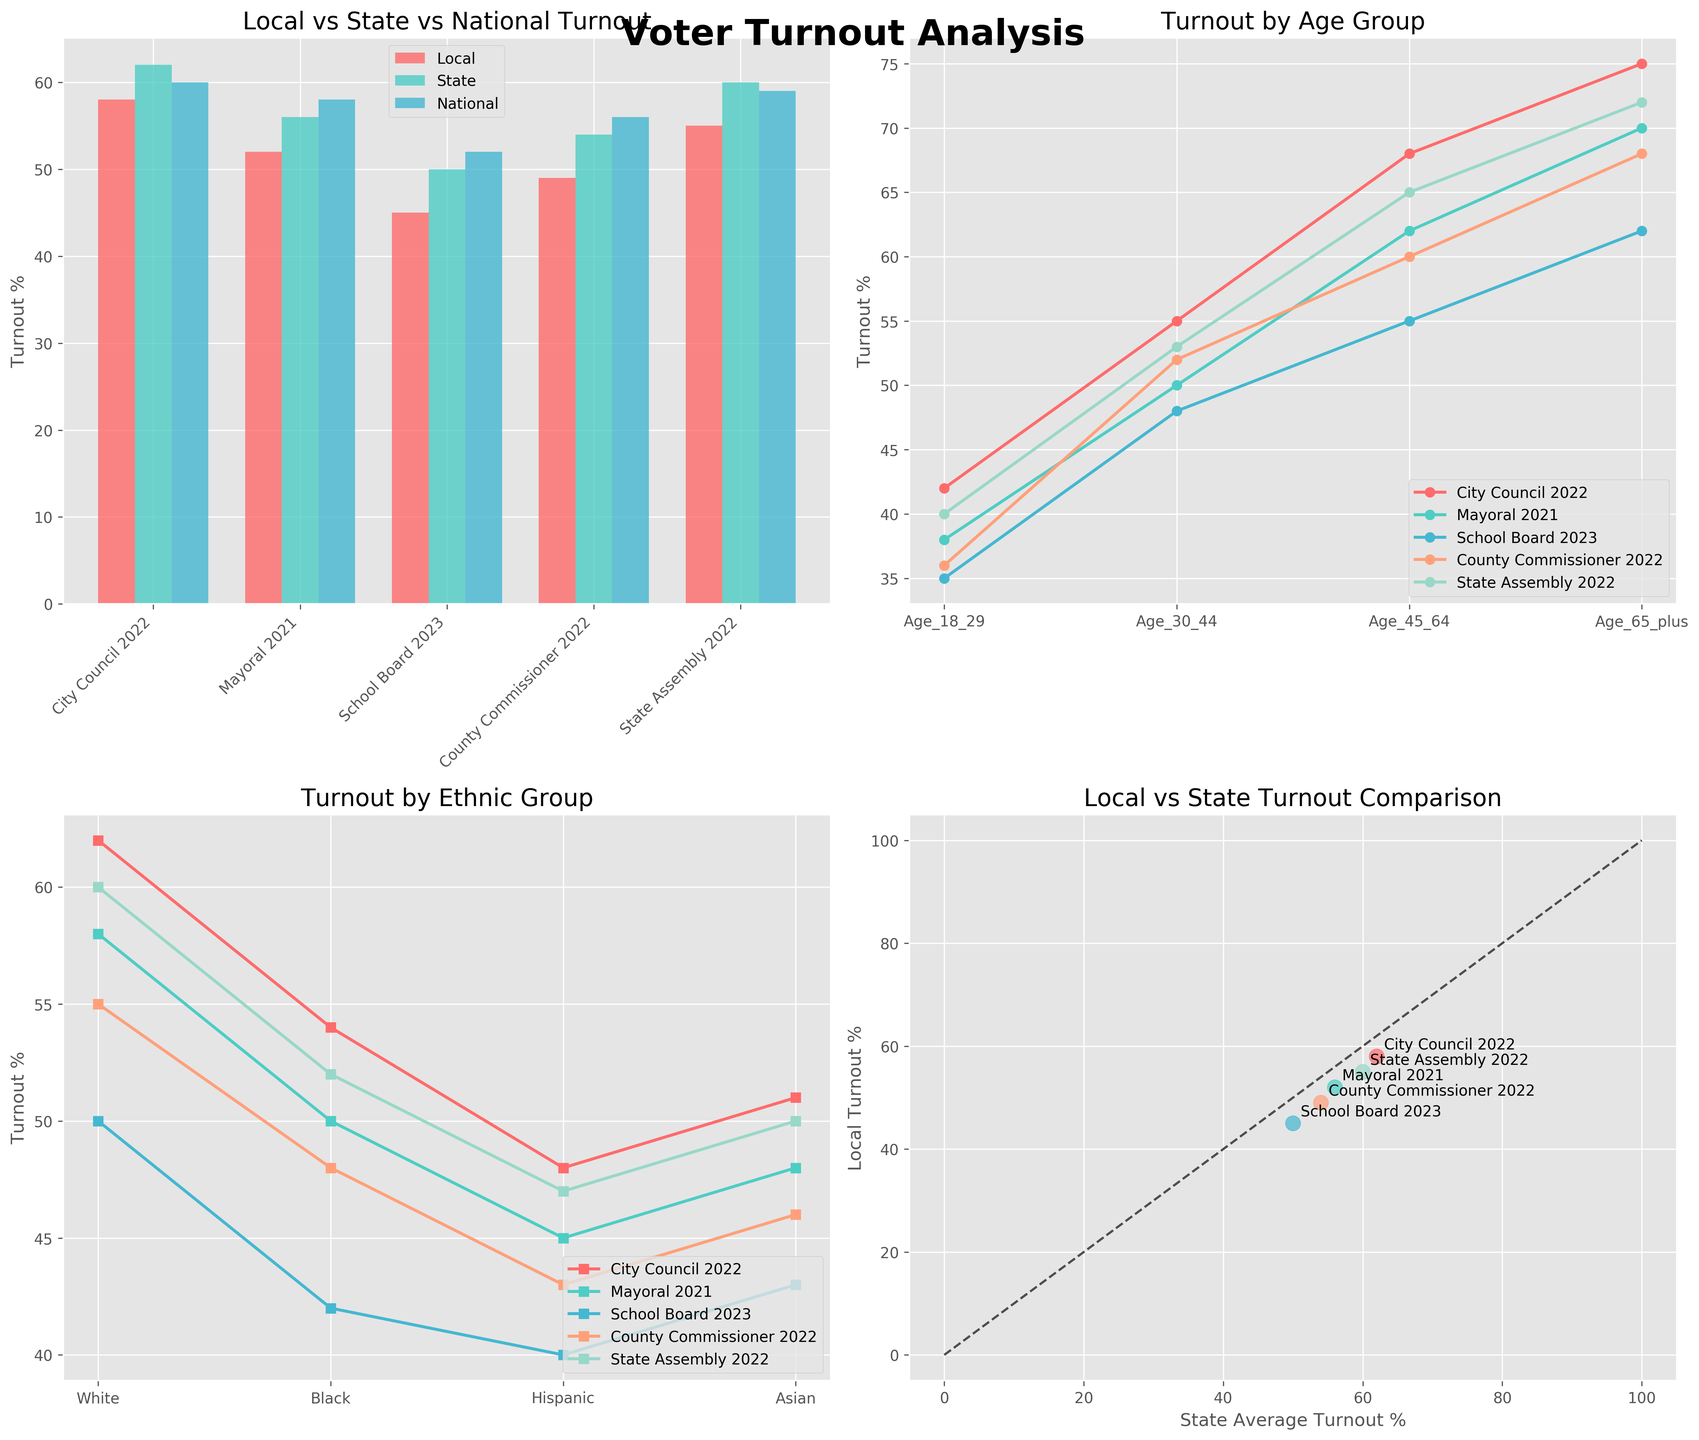What is the title of the entire figure? The title of the entire figure is located at the top center of the figure. By looking at the label, we can see it reads "Voter Turnout Analysis".
Answer: Voter Turnout Analysis How many elections are compared in the figure? To determine the number of elections compared, we can count the data points or categories on the x-axis in any of the subplots. All subplots feature the same elections: City Council 2022, Mayoral 2021, School Board 2023, County Commissioner 2022, and State Assembly 2022.
Answer: 5 Which election had the highest local voter turnout? By looking at the heights of the red bars representing local voter turnout in the first subplot, we identify that the "City Council 2022" election had the highest turnout.
Answer: City Council 2022 What is the overall trend in voter turnout across different age groups? Observing the lines in the second subplot, which depicts turnout by age group, we see that voter turnout generally increases with age across all elections. Specifically, turnouts are lowest among Age_18_29 and highest among Age_65_plus.
Answer: Increases with age In which election did the Hispanic group show the lowest turnout? In the third subplot, where turnout by ethnic group is plotted, we check the series representing Hispanic turnout and identify that the "School Board 2023" election had the lowest turnout for the Hispanic group.
Answer: School Board 2023 Which ethnic group had the highest turnout in the "Mayoral 2021" election? In the third subplot, where turnout by ethnic group is represented, we compare the plotted points for the "Mayoral 2021" line, determining that the "White" ethnic group had the highest turnout.
Answer: White How does the local turnout for the "County Commissioner 2022" election compare with the state average turnout for the same election? By looking at the scatter plot in the last subplot, identifying the point for "County Commissioner 2022" and noting both the x and y coordinates, we see that the local turnout (49%) is slightly lower than the state average (54%).
Answer: Local lower than state Which election has a wider gap between local and national turnout? In the first subplot, we look at the difference between the heights of the red and blue bars for each election. The "School Board 2023" election shows the most significant gap with a local turnout at 45% and a national average at 52%.
Answer: School Board 2023 What is the voter turnout for "Age_30_44" during the "State Assembly 2022" election? In the second subplot, follow the line for "State Assembly 2022" and read the value corresponding to "Age_30_44". The voter turnout for "Age_30_44" during this election is 53%.
Answer: 53% How do the turnouts for the "Black" group in local elections compare across all elections? In the third subplot, examine the line representing "Black" turnout across all elections. We observe the following values: City Council 2022: 54%, Mayoral 2021: 50%, School Board 2023: 42%, County Commissioner 2022: 48%, State Assembly 2022: 52%. Summarizing, "Black" turnout hovers between 42% and 54%.
Answer: 42% to 54% 